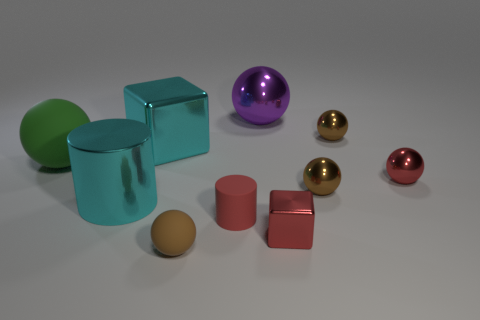What color is the matte ball that is the same size as the red shiny cube?
Your answer should be compact. Brown. How many objects are either large cyan things behind the large cyan metallic cylinder or tiny metallic balls?
Your answer should be very brief. 4. There is a big metallic thing that is the same color as the metallic cylinder; what shape is it?
Give a very brief answer. Cube. What material is the big ball on the right side of the big green ball that is behind the large metal cylinder made of?
Your answer should be compact. Metal. Is there a big object that has the same material as the big purple ball?
Your response must be concise. Yes. There is a thing in front of the tiny metallic block; is there a red metallic cube that is in front of it?
Offer a very short reply. No. There is a tiny brown object to the left of the red matte cylinder; what material is it?
Keep it short and to the point. Rubber. Does the large matte thing have the same shape as the brown matte object?
Your answer should be compact. Yes. The metallic block that is on the right side of the ball in front of the tiny matte object that is behind the brown rubber sphere is what color?
Offer a very short reply. Red. How many purple things have the same shape as the small brown matte thing?
Keep it short and to the point. 1. 